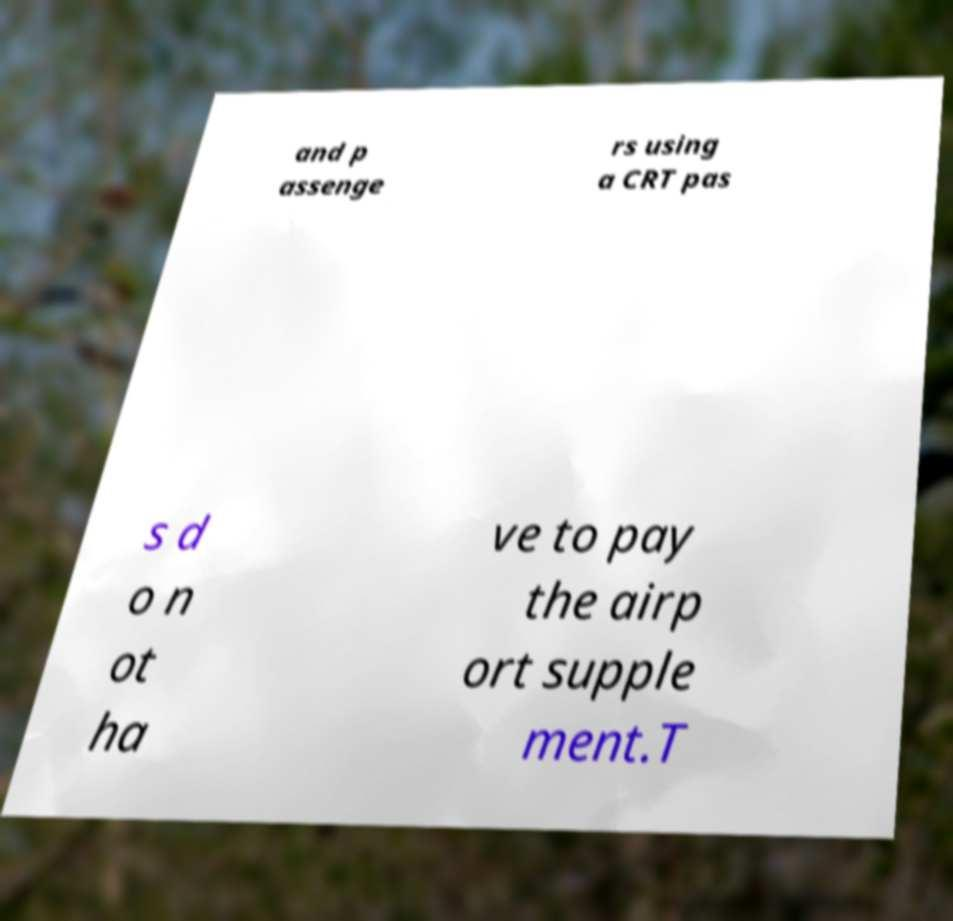Can you accurately transcribe the text from the provided image for me? and p assenge rs using a CRT pas s d o n ot ha ve to pay the airp ort supple ment.T 